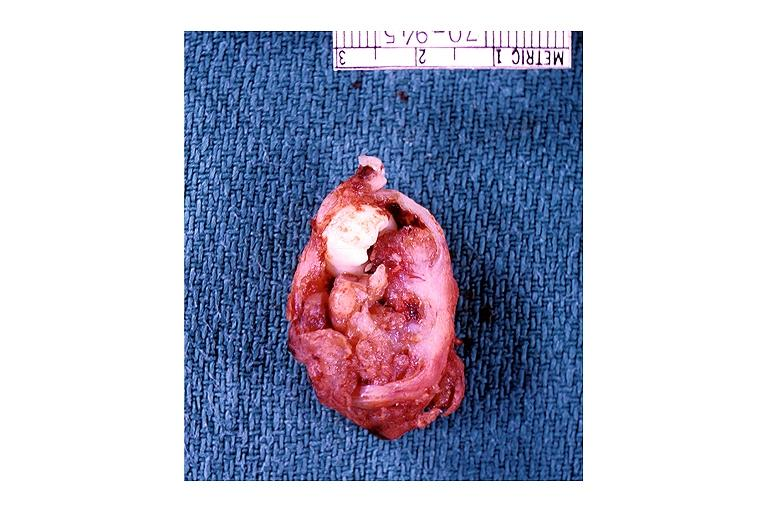s oral present?
Answer the question using a single word or phrase. Yes 